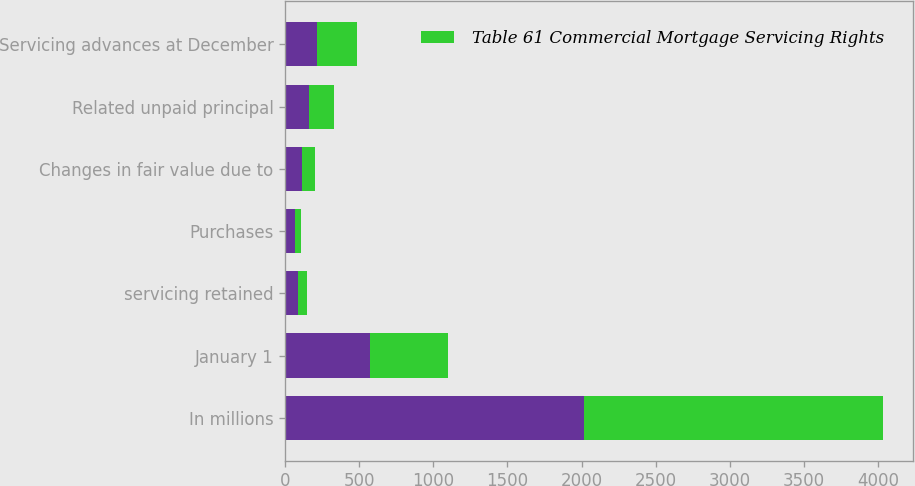Convert chart to OTSL. <chart><loc_0><loc_0><loc_500><loc_500><stacked_bar_chart><ecel><fcel>In millions<fcel>January 1<fcel>servicing retained<fcel>Purchases<fcel>Changes in fair value due to<fcel>Related unpaid principal<fcel>Servicing advances at December<nl><fcel>nan<fcel>2017<fcel>576<fcel>88<fcel>69<fcel>111<fcel>164<fcel>217<nl><fcel>Table 61 Commercial Mortgage Servicing Rights<fcel>2016<fcel>526<fcel>61<fcel>36<fcel>92<fcel>164<fcel>265<nl></chart> 